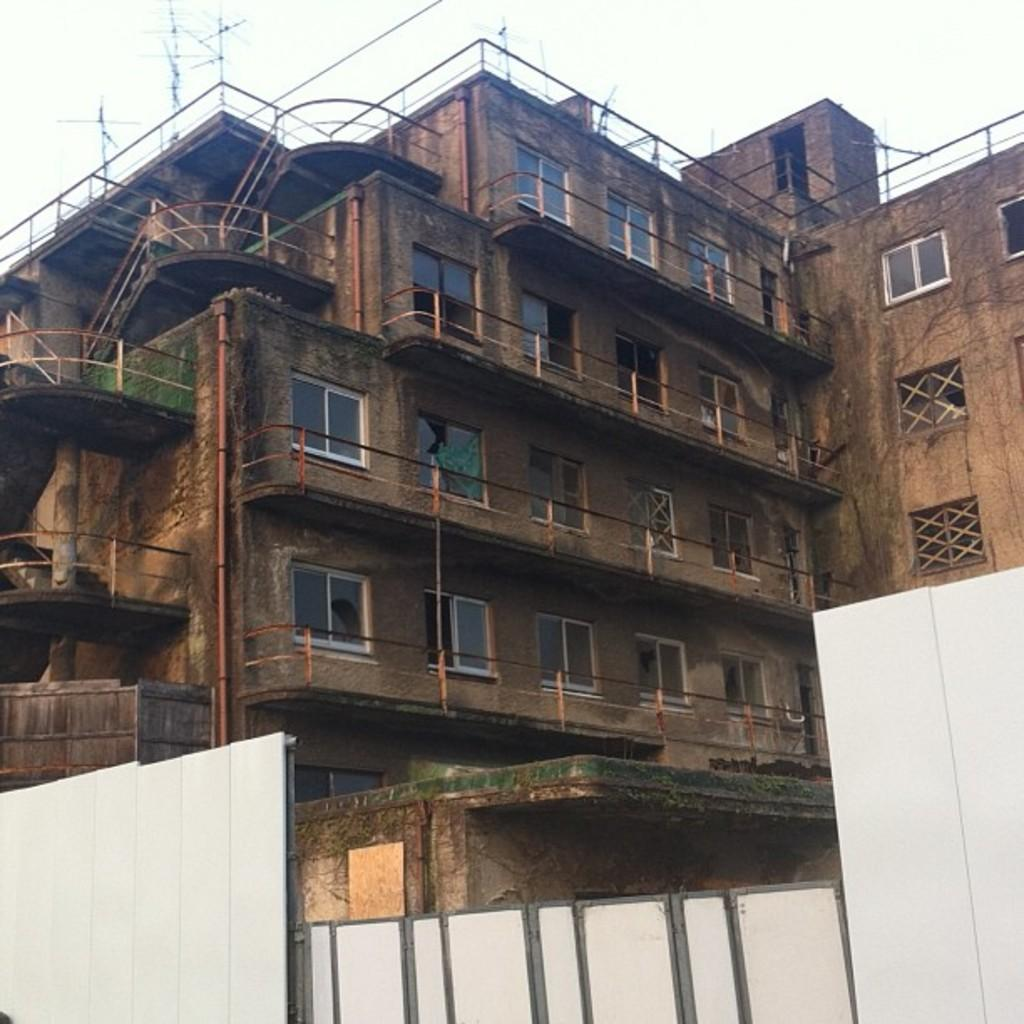What type of structure is visible in the image? There is a building with windows in the image. What is located at the bottom of the image? There is a gate at the bottom of the image. What type of barrier is present in the image? There is fencing in the image. What is visible at the top of the image? The sky is visible at the top of the image. What type of notebook is being used to record the argument in the image? There is no notebook or argument present in the image. 